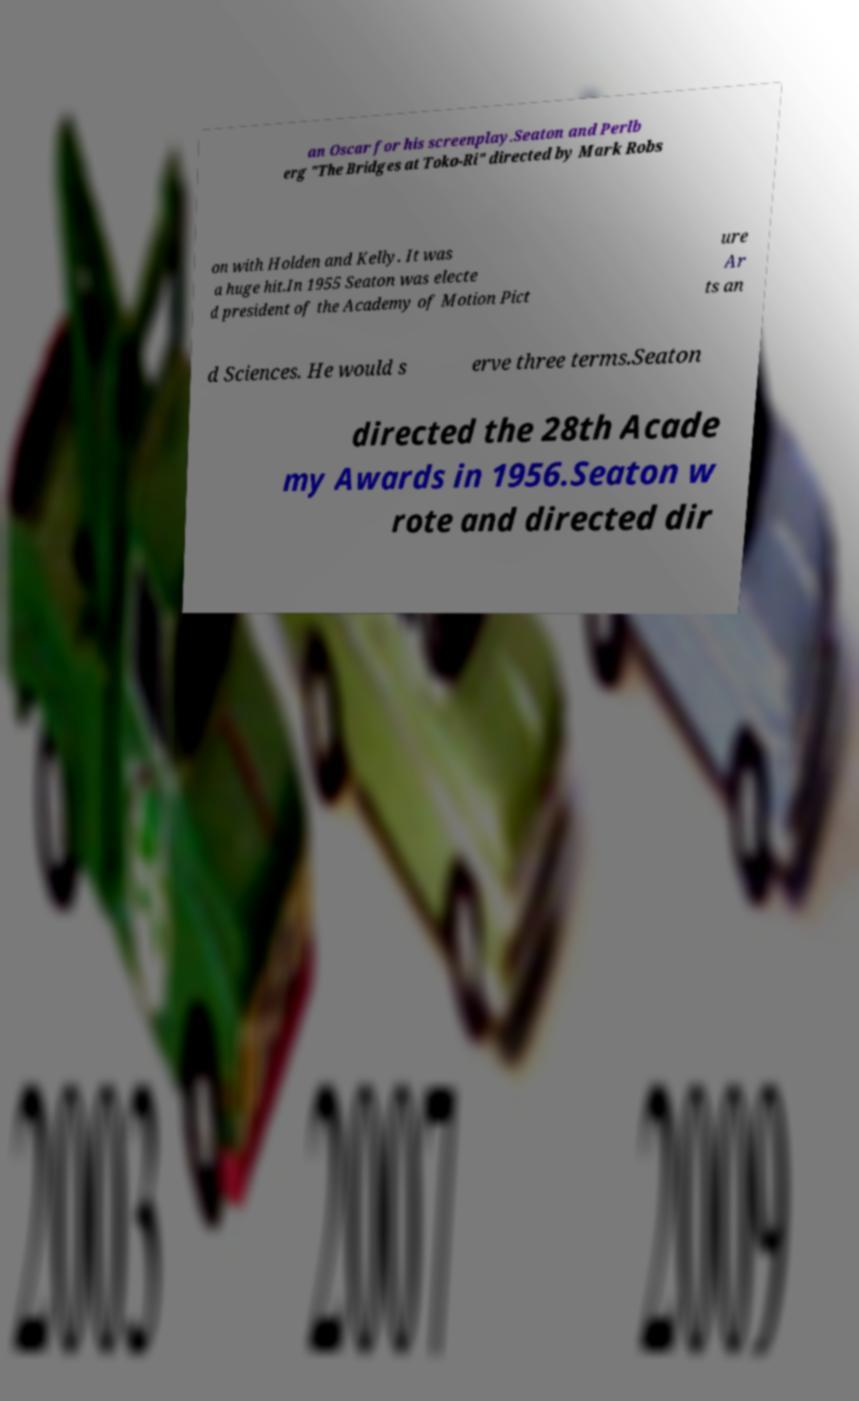Please read and relay the text visible in this image. What does it say? an Oscar for his screenplay.Seaton and Perlb erg "The Bridges at Toko-Ri" directed by Mark Robs on with Holden and Kelly. It was a huge hit.In 1955 Seaton was electe d president of the Academy of Motion Pict ure Ar ts an d Sciences. He would s erve three terms.Seaton directed the 28th Acade my Awards in 1956.Seaton w rote and directed dir 